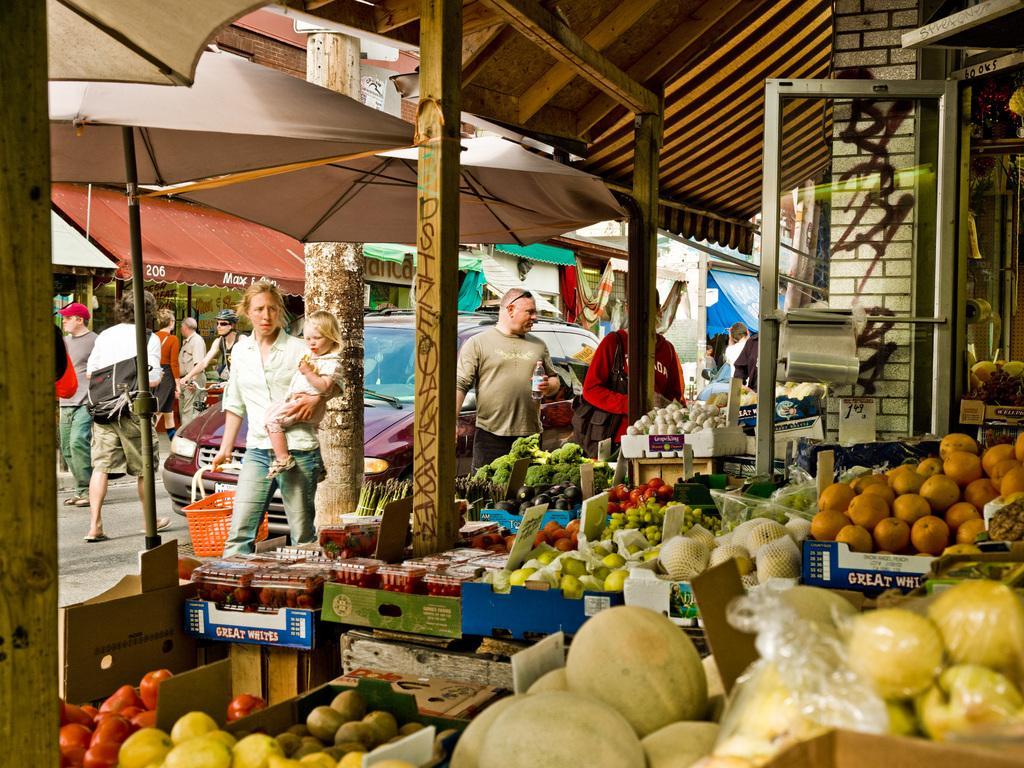Describe this image in one or two sentences. In this image, I can see a shop with boards, fruits and vegetables in the baskets. On the right side of the image, I can see a glass door. In front of the shop, there are few people standing, umbrellas with poles, a pole, a person riding bicycle and I can see a vehicle on the road. In the background, there are few other shops. 